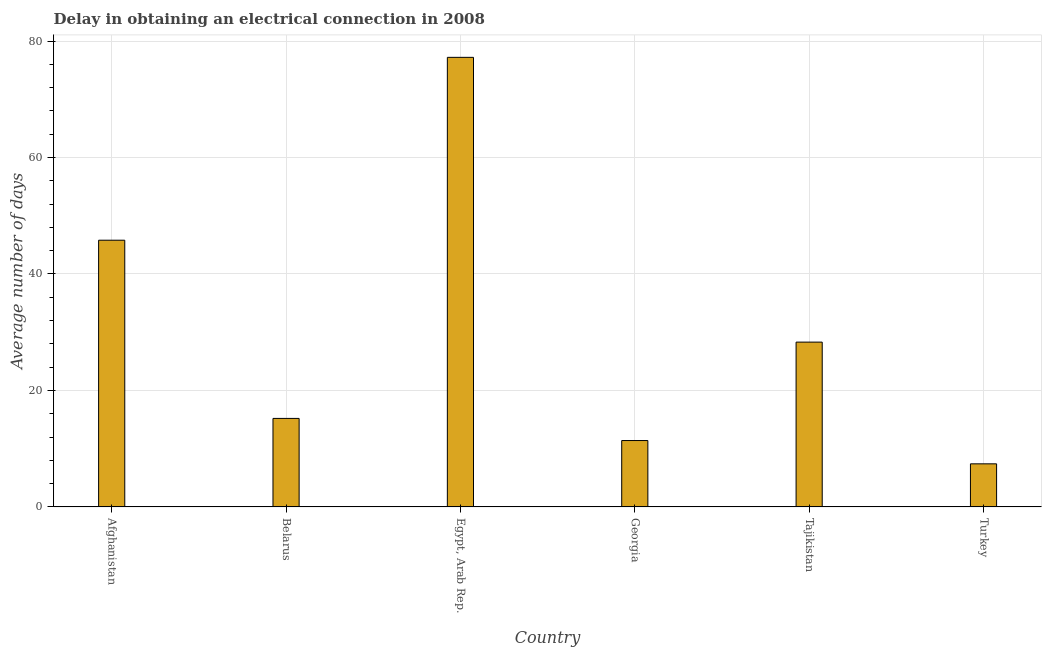What is the title of the graph?
Provide a succinct answer. Delay in obtaining an electrical connection in 2008. What is the label or title of the X-axis?
Offer a very short reply. Country. What is the label or title of the Y-axis?
Your response must be concise. Average number of days. Across all countries, what is the maximum dalay in electrical connection?
Provide a short and direct response. 77.2. In which country was the dalay in electrical connection maximum?
Offer a very short reply. Egypt, Arab Rep. In which country was the dalay in electrical connection minimum?
Offer a terse response. Turkey. What is the sum of the dalay in electrical connection?
Your answer should be very brief. 185.3. What is the difference between the dalay in electrical connection in Belarus and Tajikistan?
Provide a short and direct response. -13.1. What is the average dalay in electrical connection per country?
Provide a succinct answer. 30.88. What is the median dalay in electrical connection?
Your answer should be compact. 21.75. In how many countries, is the dalay in electrical connection greater than 20 days?
Your answer should be compact. 3. What is the ratio of the dalay in electrical connection in Egypt, Arab Rep. to that in Tajikistan?
Provide a succinct answer. 2.73. Is the dalay in electrical connection in Afghanistan less than that in Tajikistan?
Give a very brief answer. No. Is the difference between the dalay in electrical connection in Afghanistan and Tajikistan greater than the difference between any two countries?
Offer a terse response. No. What is the difference between the highest and the second highest dalay in electrical connection?
Offer a very short reply. 31.4. Is the sum of the dalay in electrical connection in Egypt, Arab Rep. and Tajikistan greater than the maximum dalay in electrical connection across all countries?
Ensure brevity in your answer.  Yes. What is the difference between the highest and the lowest dalay in electrical connection?
Make the answer very short. 69.8. How many bars are there?
Make the answer very short. 6. What is the Average number of days in Afghanistan?
Ensure brevity in your answer.  45.8. What is the Average number of days of Belarus?
Provide a succinct answer. 15.2. What is the Average number of days in Egypt, Arab Rep.?
Your response must be concise. 77.2. What is the Average number of days of Tajikistan?
Your answer should be compact. 28.3. What is the difference between the Average number of days in Afghanistan and Belarus?
Ensure brevity in your answer.  30.6. What is the difference between the Average number of days in Afghanistan and Egypt, Arab Rep.?
Offer a terse response. -31.4. What is the difference between the Average number of days in Afghanistan and Georgia?
Your answer should be very brief. 34.4. What is the difference between the Average number of days in Afghanistan and Turkey?
Your answer should be compact. 38.4. What is the difference between the Average number of days in Belarus and Egypt, Arab Rep.?
Offer a very short reply. -62. What is the difference between the Average number of days in Belarus and Georgia?
Your response must be concise. 3.8. What is the difference between the Average number of days in Belarus and Tajikistan?
Provide a succinct answer. -13.1. What is the difference between the Average number of days in Egypt, Arab Rep. and Georgia?
Your response must be concise. 65.8. What is the difference between the Average number of days in Egypt, Arab Rep. and Tajikistan?
Ensure brevity in your answer.  48.9. What is the difference between the Average number of days in Egypt, Arab Rep. and Turkey?
Ensure brevity in your answer.  69.8. What is the difference between the Average number of days in Georgia and Tajikistan?
Offer a terse response. -16.9. What is the difference between the Average number of days in Georgia and Turkey?
Offer a terse response. 4. What is the difference between the Average number of days in Tajikistan and Turkey?
Your response must be concise. 20.9. What is the ratio of the Average number of days in Afghanistan to that in Belarus?
Your answer should be compact. 3.01. What is the ratio of the Average number of days in Afghanistan to that in Egypt, Arab Rep.?
Provide a short and direct response. 0.59. What is the ratio of the Average number of days in Afghanistan to that in Georgia?
Keep it short and to the point. 4.02. What is the ratio of the Average number of days in Afghanistan to that in Tajikistan?
Provide a succinct answer. 1.62. What is the ratio of the Average number of days in Afghanistan to that in Turkey?
Your answer should be very brief. 6.19. What is the ratio of the Average number of days in Belarus to that in Egypt, Arab Rep.?
Your answer should be compact. 0.2. What is the ratio of the Average number of days in Belarus to that in Georgia?
Offer a terse response. 1.33. What is the ratio of the Average number of days in Belarus to that in Tajikistan?
Your answer should be compact. 0.54. What is the ratio of the Average number of days in Belarus to that in Turkey?
Make the answer very short. 2.05. What is the ratio of the Average number of days in Egypt, Arab Rep. to that in Georgia?
Keep it short and to the point. 6.77. What is the ratio of the Average number of days in Egypt, Arab Rep. to that in Tajikistan?
Keep it short and to the point. 2.73. What is the ratio of the Average number of days in Egypt, Arab Rep. to that in Turkey?
Your answer should be compact. 10.43. What is the ratio of the Average number of days in Georgia to that in Tajikistan?
Your answer should be very brief. 0.4. What is the ratio of the Average number of days in Georgia to that in Turkey?
Offer a very short reply. 1.54. What is the ratio of the Average number of days in Tajikistan to that in Turkey?
Your answer should be very brief. 3.82. 